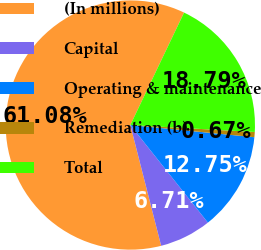Convert chart. <chart><loc_0><loc_0><loc_500><loc_500><pie_chart><fcel>(In millions)<fcel>Capital<fcel>Operating & maintenance<fcel>Remediation (b)<fcel>Total<nl><fcel>61.07%<fcel>6.71%<fcel>12.75%<fcel>0.67%<fcel>18.79%<nl></chart> 